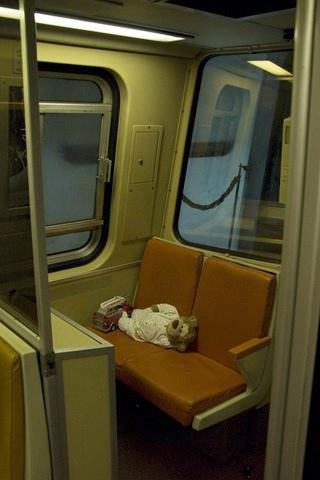Identify the type of light fixture found in the image. A long rectangular light on the ceiling. What is the main interaction between the objects in the image? The teddy bear and the red fire truck are both placed on a bus seat next to each other. List the colors found in the image. Gray, yellow, brown, white, and red. Describe the outfit worn by the teddy bear. The teddy bear is wearing a white garment, possibly pajamas. What type of vehicle is depicted in the image? The image shows the interior of a bus. Count the number of toys present in the image. There are two toys: a red fire truck and a teddy bear. Mention the color of the seat covers. The seat covers are orange. What are the main features found on the teddy bear's face? The teddy bear has a nose, and two ears. Identify the two main objects on the bus seat. A red fire truck and a teddy bear wearing a white outfit. Can you find a purple cat wearing a hat in the image? It's located near the fire truck. No, it's not mentioned in the image. 